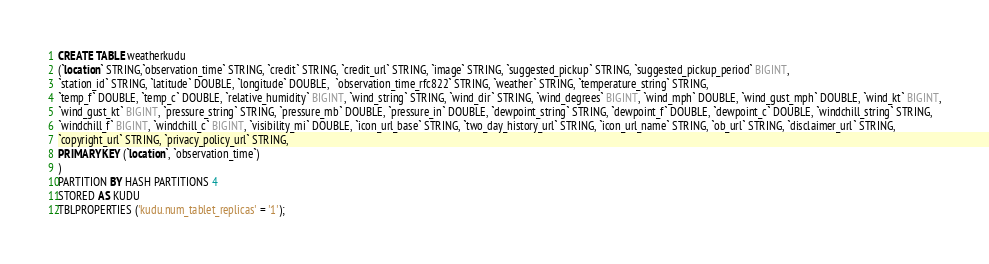Convert code to text. <code><loc_0><loc_0><loc_500><loc_500><_SQL_>CREATE TABLE weatherkudu
(`location` STRING,`observation_time` STRING, `credit` STRING, `credit_url` STRING, `image` STRING, `suggested_pickup` STRING, `suggested_pickup_period` BIGINT,
`station_id` STRING, `latitude` DOUBLE, `longitude` DOUBLE,  `observation_time_rfc822` STRING, `weather` STRING, `temperature_string` STRING,
`temp_f` DOUBLE, `temp_c` DOUBLE, `relative_humidity` BIGINT, `wind_string` STRING, `wind_dir` STRING, `wind_degrees` BIGINT, `wind_mph` DOUBLE, `wind_gust_mph` DOUBLE, `wind_kt` BIGINT,
`wind_gust_kt` BIGINT, `pressure_string` STRING, `pressure_mb` DOUBLE, `pressure_in` DOUBLE, `dewpoint_string` STRING, `dewpoint_f` DOUBLE, `dewpoint_c` DOUBLE, `windchill_string` STRING,
`windchill_f` BIGINT, `windchill_c` BIGINT, `visibility_mi` DOUBLE, `icon_url_base` STRING, `two_day_history_url` STRING, `icon_url_name` STRING, `ob_url` STRING, `disclaimer_url` STRING,
`copyright_url` STRING, `privacy_policy_url` STRING,
PRIMARY KEY (`location`, `observation_time`)
)
PARTITION BY HASH PARTITIONS 4
STORED AS KUDU
TBLPROPERTIES ('kudu.num_tablet_replicas' = '1');
</code> 